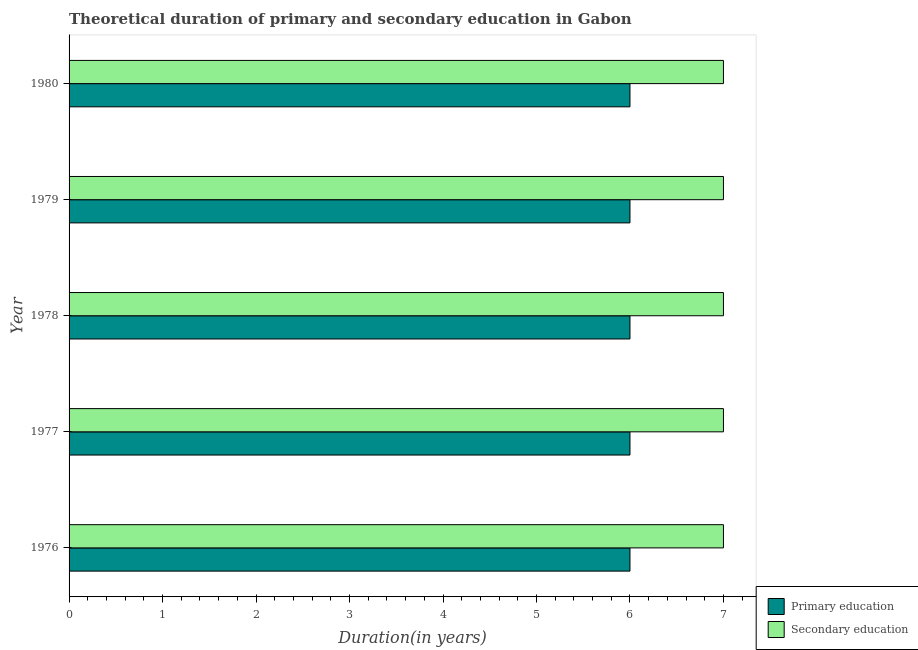How many different coloured bars are there?
Give a very brief answer. 2. Are the number of bars per tick equal to the number of legend labels?
Offer a terse response. Yes. Are the number of bars on each tick of the Y-axis equal?
Your answer should be compact. Yes. What is the duration of secondary education in 1978?
Provide a short and direct response. 7. Across all years, what is the minimum duration of primary education?
Keep it short and to the point. 6. In which year was the duration of secondary education maximum?
Give a very brief answer. 1976. In which year was the duration of primary education minimum?
Your answer should be compact. 1976. What is the total duration of primary education in the graph?
Your response must be concise. 30. What is the difference between the duration of secondary education in 1976 and that in 1977?
Your response must be concise. 0. What is the difference between the duration of secondary education in 1980 and the duration of primary education in 1976?
Provide a short and direct response. 1. In the year 1976, what is the difference between the duration of primary education and duration of secondary education?
Provide a succinct answer. -1. In how many years, is the duration of primary education greater than 3.8 years?
Your response must be concise. 5. What is the difference between the highest and the lowest duration of secondary education?
Make the answer very short. 0. Is the sum of the duration of primary education in 1977 and 1979 greater than the maximum duration of secondary education across all years?
Offer a terse response. Yes. What does the 1st bar from the top in 1976 represents?
Provide a short and direct response. Secondary education. What does the 2nd bar from the bottom in 1976 represents?
Your answer should be compact. Secondary education. How many years are there in the graph?
Ensure brevity in your answer.  5. Does the graph contain any zero values?
Your answer should be very brief. No. Where does the legend appear in the graph?
Keep it short and to the point. Bottom right. How are the legend labels stacked?
Keep it short and to the point. Vertical. What is the title of the graph?
Provide a succinct answer. Theoretical duration of primary and secondary education in Gabon. What is the label or title of the X-axis?
Ensure brevity in your answer.  Duration(in years). What is the label or title of the Y-axis?
Offer a terse response. Year. What is the Duration(in years) of Primary education in 1977?
Your answer should be compact. 6. What is the Duration(in years) of Primary education in 1978?
Give a very brief answer. 6. What is the Duration(in years) in Secondary education in 1980?
Offer a terse response. 7. Across all years, what is the maximum Duration(in years) of Primary education?
Provide a succinct answer. 6. Across all years, what is the minimum Duration(in years) of Primary education?
Provide a succinct answer. 6. Across all years, what is the minimum Duration(in years) in Secondary education?
Make the answer very short. 7. What is the difference between the Duration(in years) in Primary education in 1976 and that in 1979?
Offer a very short reply. 0. What is the difference between the Duration(in years) in Primary education in 1976 and that in 1980?
Make the answer very short. 0. What is the difference between the Duration(in years) of Primary education in 1977 and that in 1979?
Make the answer very short. 0. What is the difference between the Duration(in years) in Secondary education in 1977 and that in 1979?
Your answer should be very brief. 0. What is the difference between the Duration(in years) of Secondary education in 1978 and that in 1979?
Provide a short and direct response. 0. What is the difference between the Duration(in years) in Primary education in 1978 and that in 1980?
Offer a terse response. 0. What is the difference between the Duration(in years) of Secondary education in 1979 and that in 1980?
Give a very brief answer. 0. What is the difference between the Duration(in years) in Primary education in 1976 and the Duration(in years) in Secondary education in 1979?
Ensure brevity in your answer.  -1. What is the difference between the Duration(in years) in Primary education in 1977 and the Duration(in years) in Secondary education in 1980?
Ensure brevity in your answer.  -1. What is the difference between the Duration(in years) in Primary education in 1978 and the Duration(in years) in Secondary education in 1979?
Give a very brief answer. -1. What is the difference between the Duration(in years) in Primary education in 1978 and the Duration(in years) in Secondary education in 1980?
Provide a short and direct response. -1. What is the average Duration(in years) of Primary education per year?
Your answer should be compact. 6. In the year 1977, what is the difference between the Duration(in years) in Primary education and Duration(in years) in Secondary education?
Make the answer very short. -1. In the year 1978, what is the difference between the Duration(in years) of Primary education and Duration(in years) of Secondary education?
Your response must be concise. -1. In the year 1979, what is the difference between the Duration(in years) of Primary education and Duration(in years) of Secondary education?
Your answer should be compact. -1. What is the ratio of the Duration(in years) of Primary education in 1976 to that in 1977?
Ensure brevity in your answer.  1. What is the ratio of the Duration(in years) in Primary education in 1976 to that in 1979?
Your answer should be compact. 1. What is the ratio of the Duration(in years) in Primary education in 1976 to that in 1980?
Provide a short and direct response. 1. What is the ratio of the Duration(in years) in Primary education in 1977 to that in 1979?
Give a very brief answer. 1. What is the ratio of the Duration(in years) in Primary education in 1978 to that in 1980?
Give a very brief answer. 1. What is the difference between the highest and the second highest Duration(in years) of Secondary education?
Your answer should be compact. 0. What is the difference between the highest and the lowest Duration(in years) in Primary education?
Offer a very short reply. 0. 